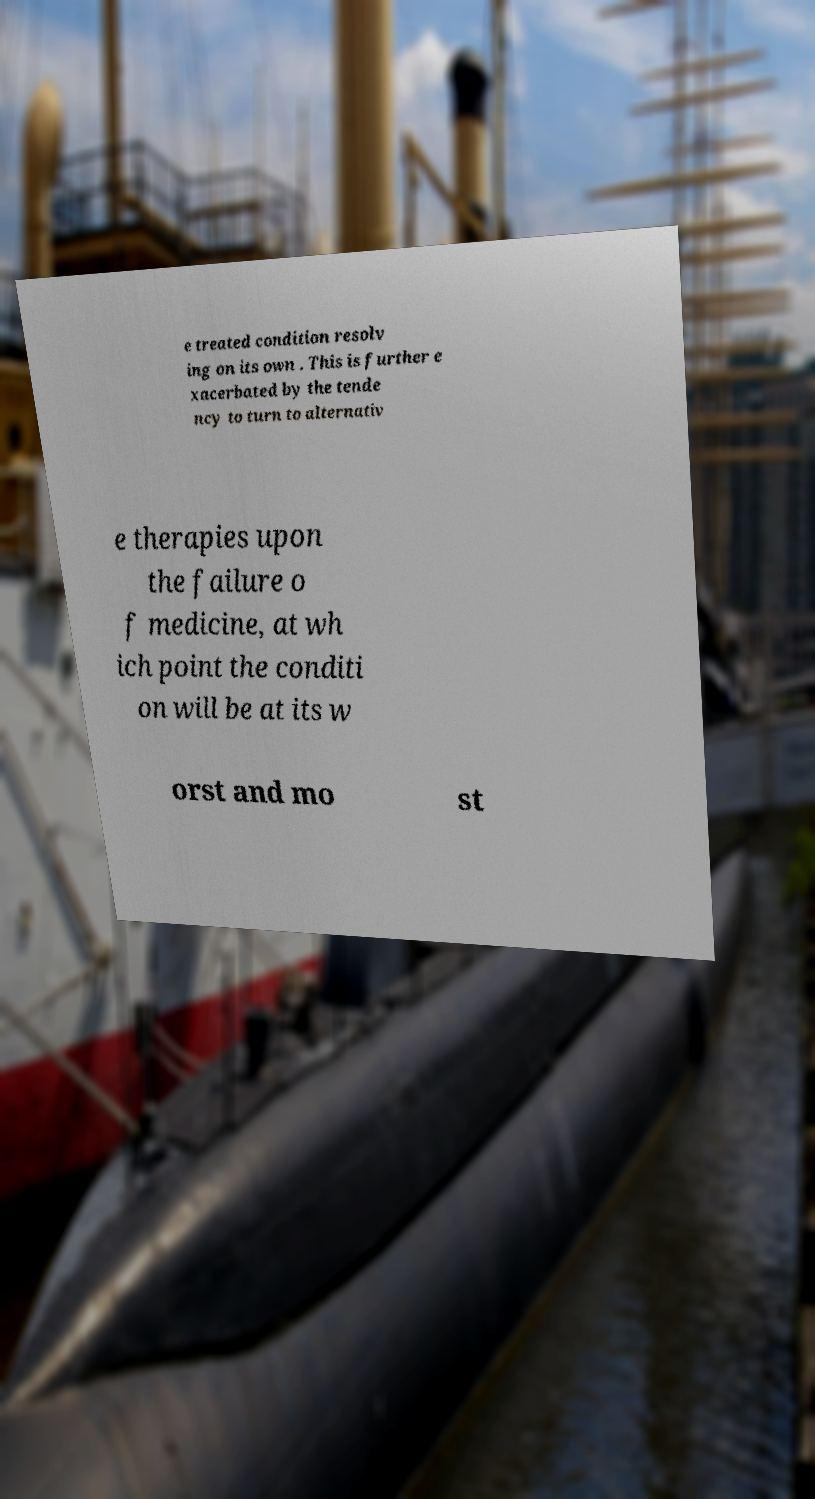Can you read and provide the text displayed in the image?This photo seems to have some interesting text. Can you extract and type it out for me? e treated condition resolv ing on its own . This is further e xacerbated by the tende ncy to turn to alternativ e therapies upon the failure o f medicine, at wh ich point the conditi on will be at its w orst and mo st 